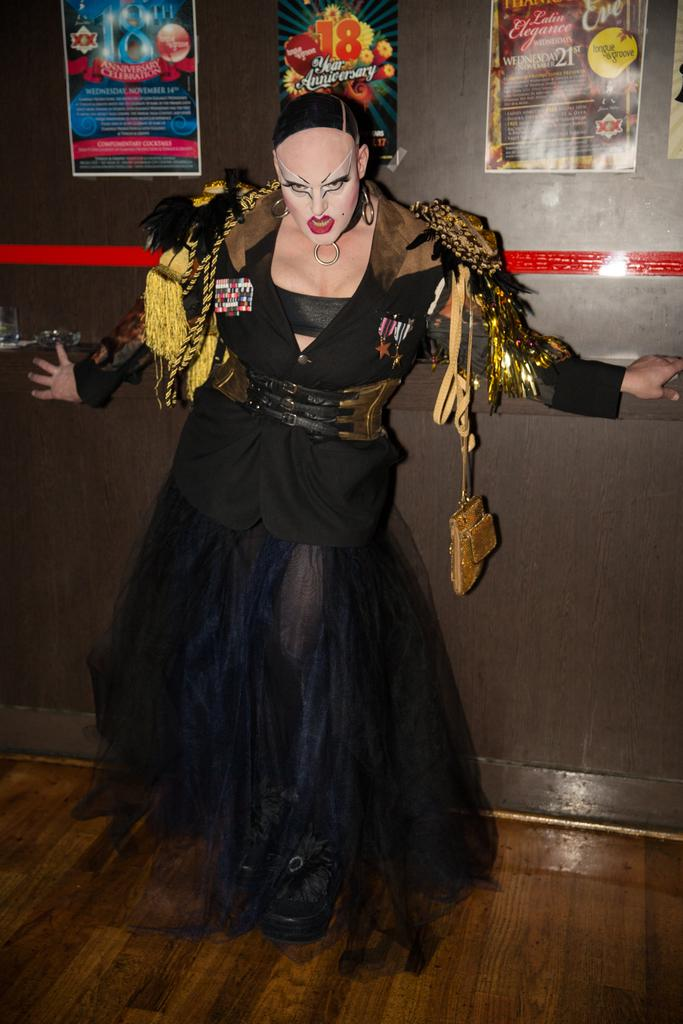Who is the main subject in the image? There is a woman in the image. What is the woman wearing? The woman is wearing a black costume. What is the woman doing in the image? The woman is giving a scary pose to the camera. What can be seen in the background of the image? There is a black wall in the background of the image. What is attached to the wall in the image? There are paper posters on the wall. What type of jelly can be seen on the woman's costume in the image? There is no jelly present on the woman's costume in the image. What appliance is being used by the woman in the image? There is no appliance being used by the woman in the image; she is simply posing for the camera. 